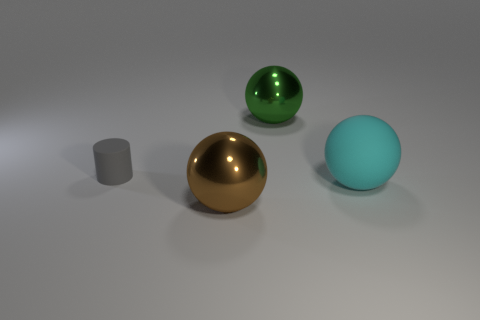Add 3 large matte spheres. How many objects exist? 7 Subtract all balls. How many objects are left? 1 Add 1 gray matte cylinders. How many gray matte cylinders are left? 2 Add 2 small gray matte cylinders. How many small gray matte cylinders exist? 3 Subtract 0 purple cylinders. How many objects are left? 4 Subtract all tiny purple balls. Subtract all large metallic balls. How many objects are left? 2 